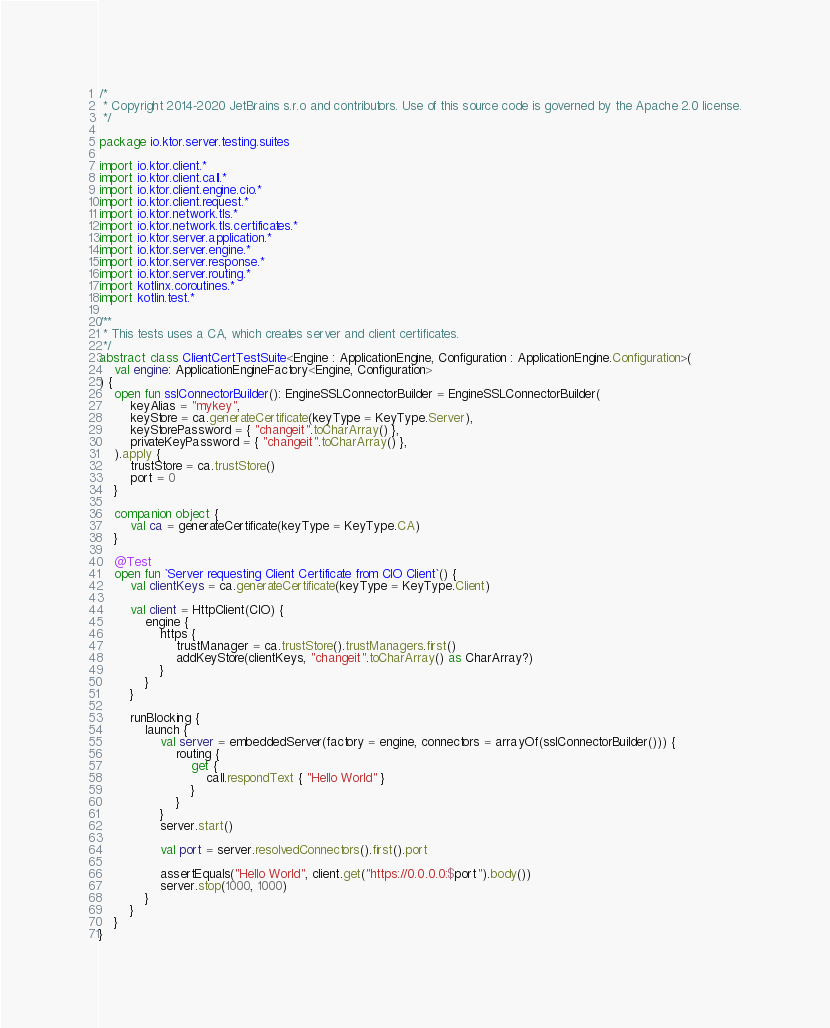<code> <loc_0><loc_0><loc_500><loc_500><_Kotlin_>/*
 * Copyright 2014-2020 JetBrains s.r.o and contributors. Use of this source code is governed by the Apache 2.0 license.
 */

package io.ktor.server.testing.suites

import io.ktor.client.*
import io.ktor.client.call.*
import io.ktor.client.engine.cio.*
import io.ktor.client.request.*
import io.ktor.network.tls.*
import io.ktor.network.tls.certificates.*
import io.ktor.server.application.*
import io.ktor.server.engine.*
import io.ktor.server.response.*
import io.ktor.server.routing.*
import kotlinx.coroutines.*
import kotlin.test.*

/**
 * This tests uses a CA, which creates server and client certificates.
 */
abstract class ClientCertTestSuite<Engine : ApplicationEngine, Configuration : ApplicationEngine.Configuration>(
    val engine: ApplicationEngineFactory<Engine, Configuration>
) {
    open fun sslConnectorBuilder(): EngineSSLConnectorBuilder = EngineSSLConnectorBuilder(
        keyAlias = "mykey",
        keyStore = ca.generateCertificate(keyType = KeyType.Server),
        keyStorePassword = { "changeit".toCharArray() },
        privateKeyPassword = { "changeit".toCharArray() },
    ).apply {
        trustStore = ca.trustStore()
        port = 0
    }

    companion object {
        val ca = generateCertificate(keyType = KeyType.CA)
    }

    @Test
    open fun `Server requesting Client Certificate from CIO Client`() {
        val clientKeys = ca.generateCertificate(keyType = KeyType.Client)

        val client = HttpClient(CIO) {
            engine {
                https {
                    trustManager = ca.trustStore().trustManagers.first()
                    addKeyStore(clientKeys, "changeit".toCharArray() as CharArray?)
                }
            }
        }

        runBlocking {
            launch {
                val server = embeddedServer(factory = engine, connectors = arrayOf(sslConnectorBuilder())) {
                    routing {
                        get {
                            call.respondText { "Hello World" }
                        }
                    }
                }
                server.start()

                val port = server.resolvedConnectors().first().port

                assertEquals("Hello World", client.get("https://0.0.0.0:$port").body())
                server.stop(1000, 1000)
            }
        }
    }
}
</code> 